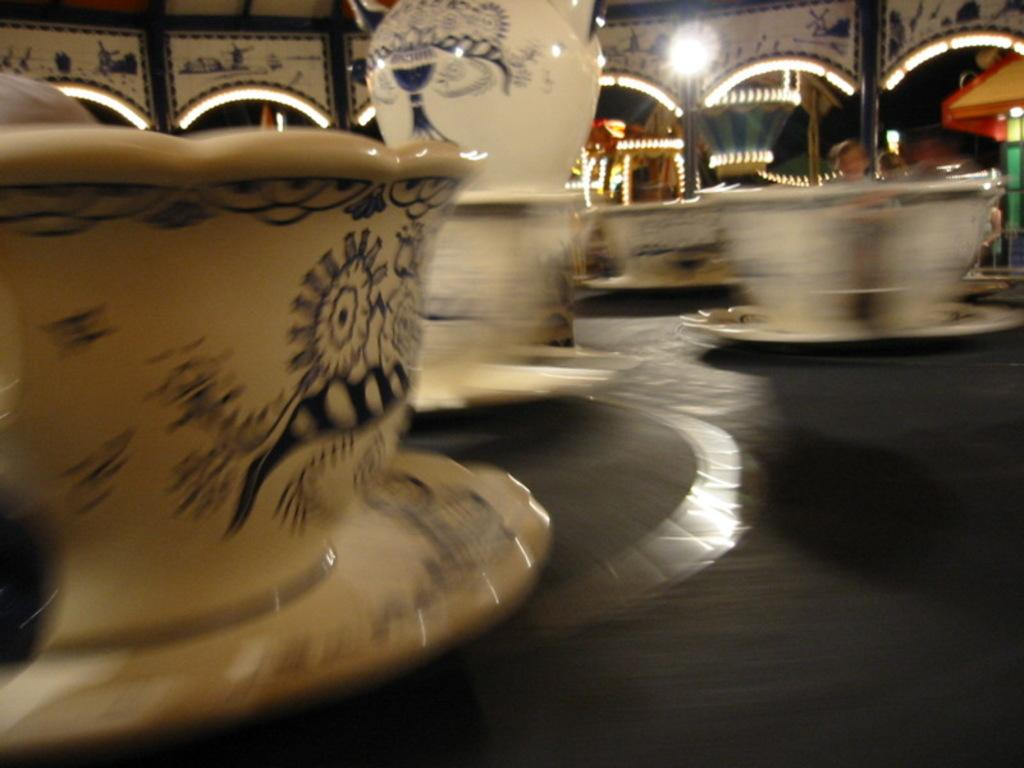What piece of furniture is present in the image? There is a table in the image. What items are placed on the table? There are cups, a saucer, and a mug on the table. What can be seen in the background of the image? There is an entrance and lighting visible in the background of the image. What type of nerve is being stimulated by the invention in the image? There is no invention or nerve present in the image; it only features a table with cups, a saucer, and a mug, along with an entrance and lighting in the background. 